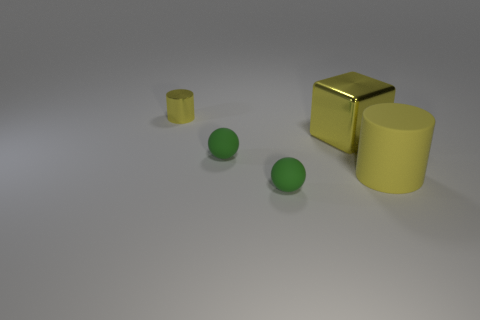How big is the yellow block on the left side of the yellow cylinder in front of the yellow shiny block?
Your answer should be compact. Large. There is a small object that is in front of the tiny yellow shiny object and behind the yellow matte thing; what color is it?
Ensure brevity in your answer.  Green. Do the tiny yellow thing and the large rubber thing have the same shape?
Your answer should be compact. Yes. There is a matte cylinder that is the same color as the metal cube; what size is it?
Keep it short and to the point. Large. What is the shape of the metallic object that is in front of the yellow cylinder on the left side of the rubber cylinder?
Ensure brevity in your answer.  Cube. There is a small yellow metallic thing; is its shape the same as the large yellow object on the right side of the big yellow metallic thing?
Provide a succinct answer. Yes. What is the color of the metallic thing that is the same size as the yellow matte thing?
Your answer should be very brief. Yellow. Is the number of small metallic things that are right of the big metallic cube less than the number of yellow shiny things that are to the right of the large matte thing?
Ensure brevity in your answer.  No. What is the shape of the yellow metallic object that is left of the tiny green thing behind the thing to the right of the large block?
Provide a short and direct response. Cylinder. There is a cylinder that is in front of the large yellow shiny cube; is it the same color as the ball in front of the large matte object?
Offer a terse response. No. 